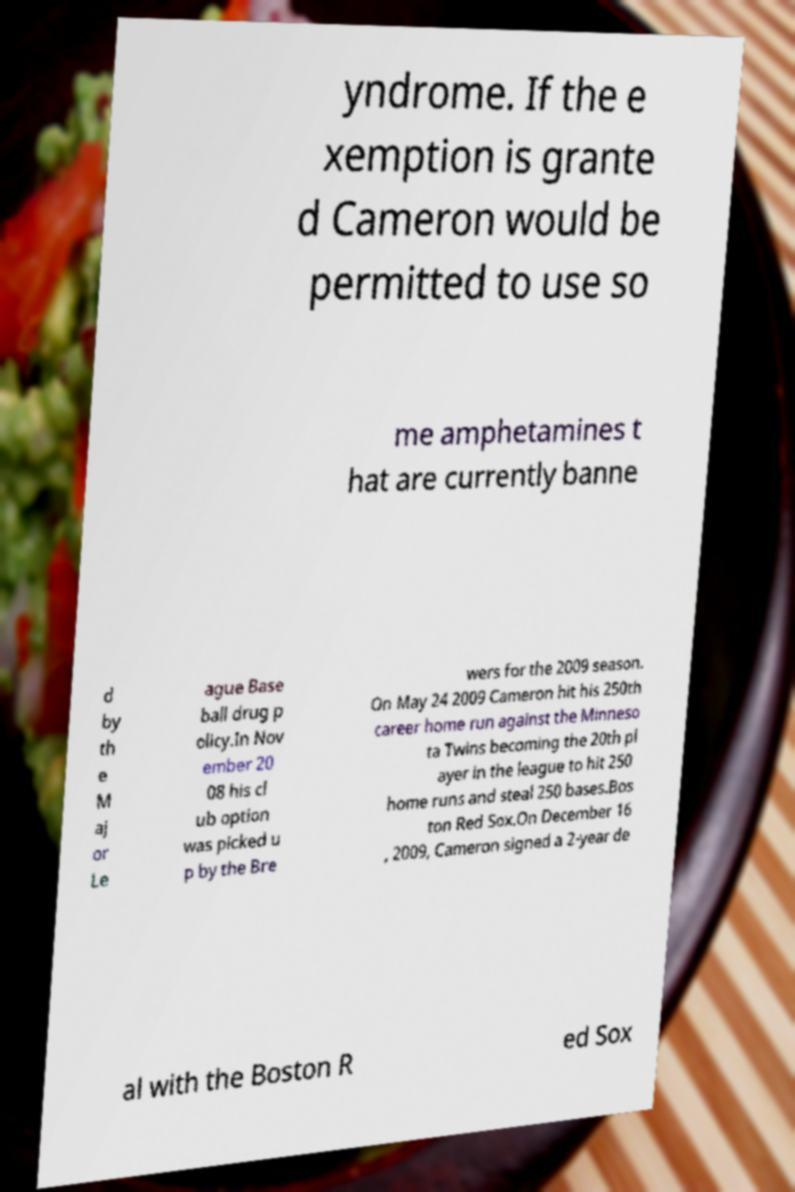What messages or text are displayed in this image? I need them in a readable, typed format. yndrome. If the e xemption is grante d Cameron would be permitted to use so me amphetamines t hat are currently banne d by th e M aj or Le ague Base ball drug p olicy.In Nov ember 20 08 his cl ub option was picked u p by the Bre wers for the 2009 season. On May 24 2009 Cameron hit his 250th career home run against the Minneso ta Twins becoming the 20th pl ayer in the league to hit 250 home runs and steal 250 bases.Bos ton Red Sox.On December 16 , 2009, Cameron signed a 2-year de al with the Boston R ed Sox 